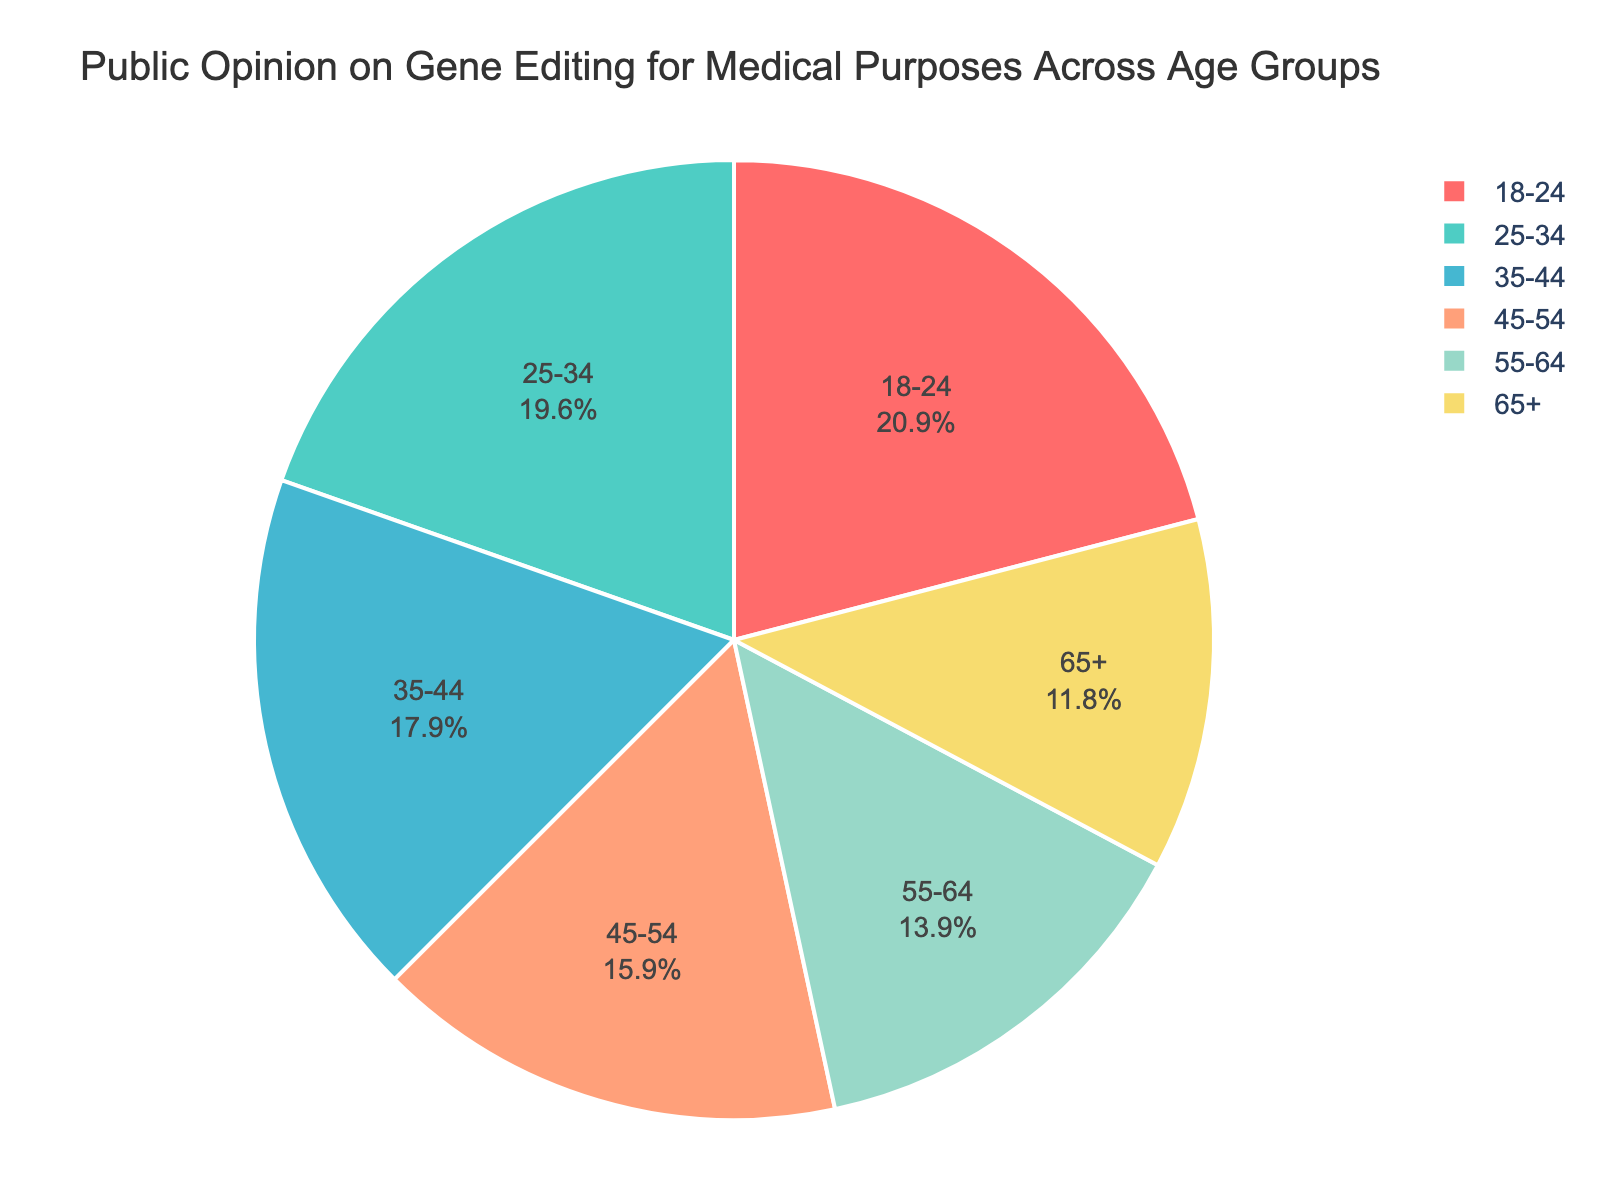What percentage of people aged 18-24 are in favor of gene editing? Based on the pie chart, the segment for the 18-24 age group shows 62%.
Answer: 62% Which age group has the lowest percentage in favor of gene editing? Observing the pie chart, the segment with the lowest percentage in favor of gene editing is the 65+ age group.
Answer: 65+ How many age groups have over 50% of people in favor of gene editing? From the pie chart, the age groups 18-24, 25-34, and 35-44 have percentages of 62%, 58%, and 53%, respectively, all above 50%. Therefore, there are three groups.
Answer: 3 What is the difference in the percentage of people in favor of gene editing between the 18-24 and 65+ age groups? From the chart, the 18-24 age group has 62% in favor and the 65+ age group has 35%. The difference is 62% - 35% = 27%.
Answer: 27% How does the opinion of the 55-64 age group compare to the 45-54 age group regarding support for gene editing? The pie chart shows that 41% of the 55-64 age group are in favor, while 47% of the 45-54 group are in favor. The 55-64 age group has a lower percentage.
Answer: Lower What is the average percentage in favor of gene editing for the age groups 25-34 and 35-44? The chart shows 58% for the 25-34 group and 53% for the 35-44 group. Their average is (58% + 53%) / 2 = 111% / 2 = 55.5%.
Answer: 55.5% Among the displayed segments, which color represents the 25-34 age group? The pie chart's legend shows colors for each age group, and the 25-34 age group is represented by green.
Answer: Green If we combine the percentages of people aged 35-44 and 45-54, what is the total percentage in favor of gene editing? The pie chart shows 53% for the 35-44 age group and 47% for the 45-54 age group. The combined percentage is 53% + 47% = 100%.
Answer: 100% Which two age groups have the smallest difference in their percentages in favor of gene editing? The smallest difference is observed between the 25-34 (58%) and 35-44 (53%) age groups. The difference is 58% - 53% = 5%.
Answer: 25-34 and 35-44 What percentage of people aged 45-54 are in favor of gene editing for medical purposes? According to the pie chart, the 45-54 age group shows 47% in favor.
Answer: 47% 